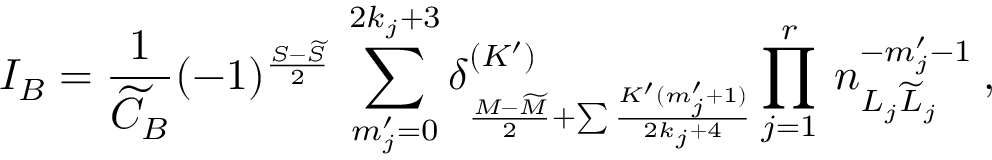Convert formula to latex. <formula><loc_0><loc_0><loc_500><loc_500>I _ { B } = \frac { 1 } { \widetilde { C } _ { B } } ( - 1 ) ^ { \frac { S - \widetilde { S } } { 2 } } \, \sum _ { m _ { j } ^ { \prime } = 0 } ^ { 2 k _ { j } + 3 } \delta _ { \frac { M - \widetilde { M } } { 2 } + \sum \frac { K ^ { \prime } ( m _ { j } ^ { \prime } + 1 ) } { 2 k _ { j } + 4 } } ^ { ( K ^ { \prime } ) } \prod _ { j = 1 } ^ { r } \, n _ { L _ { j } \widetilde { L } _ { j } } ^ { - m _ { j } ^ { \prime } - 1 } \, ,</formula> 